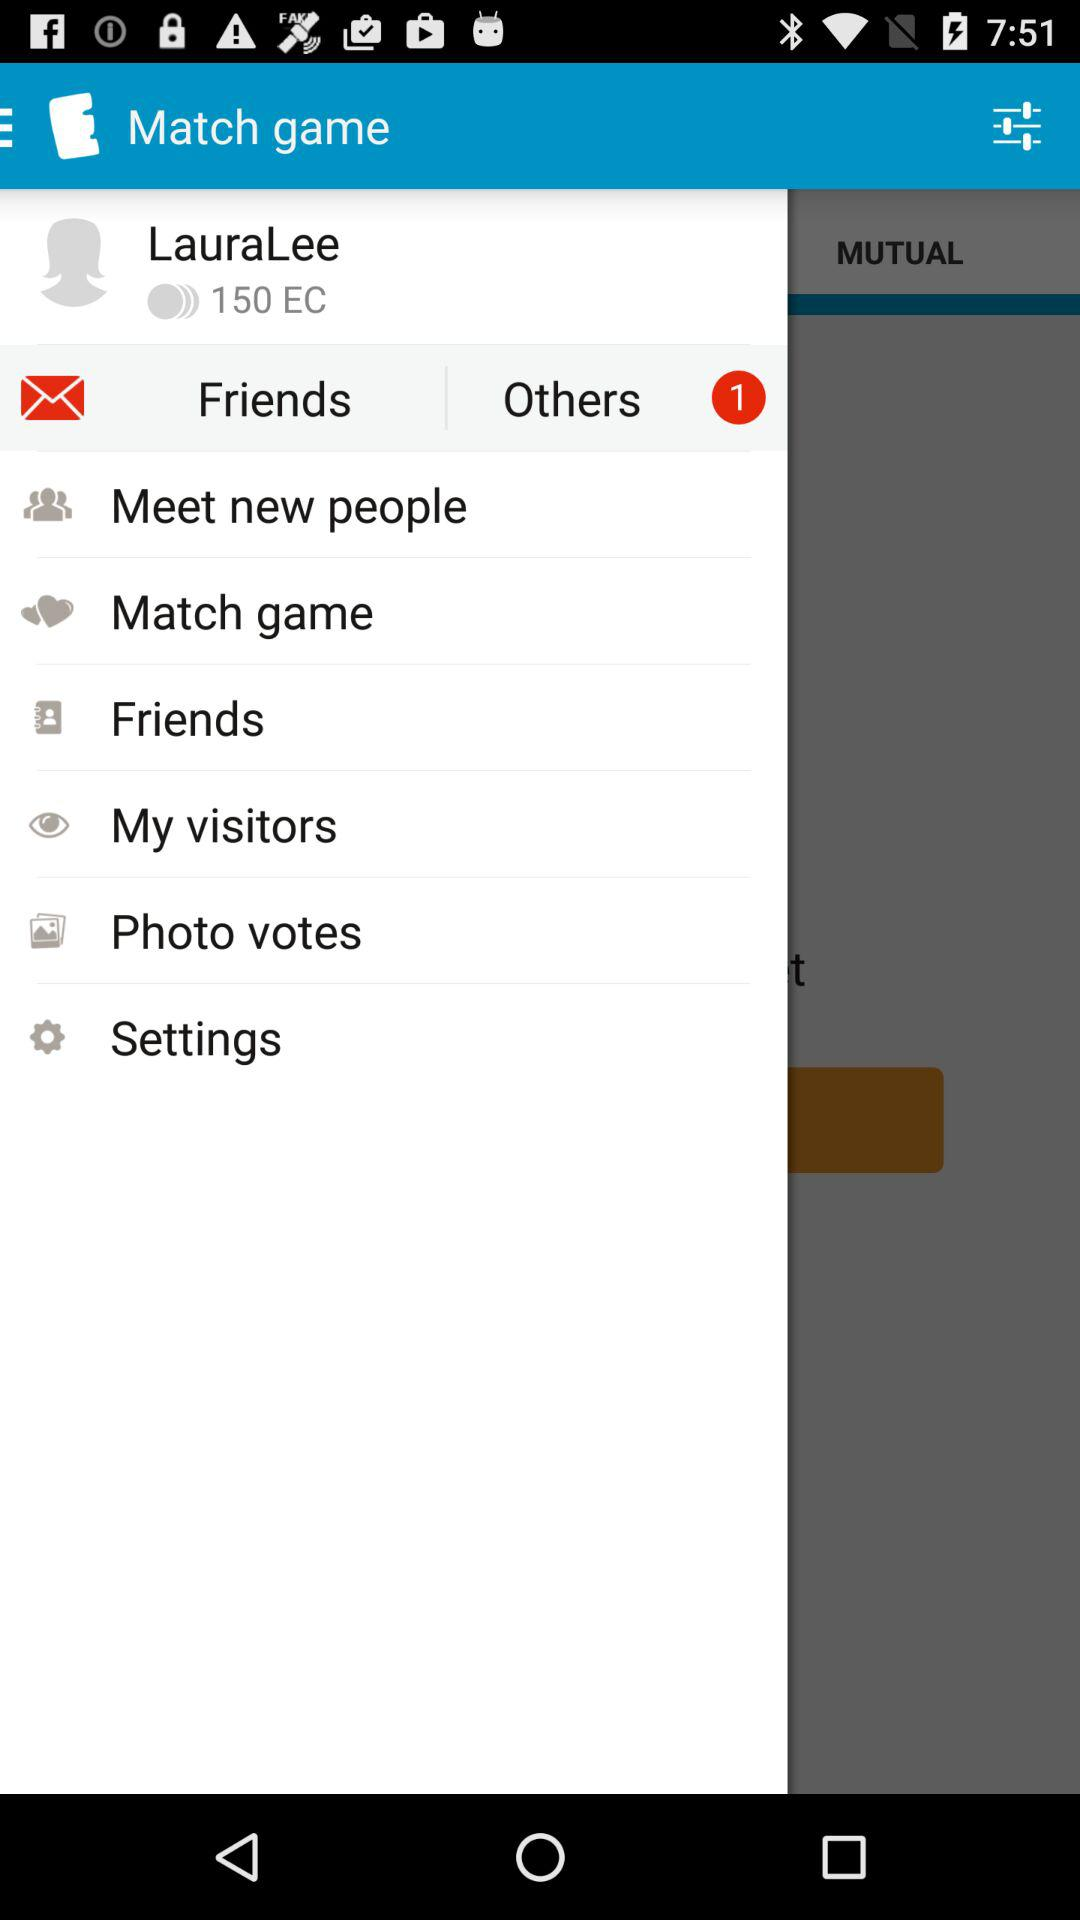What is the username? The username is "LauraLee". 